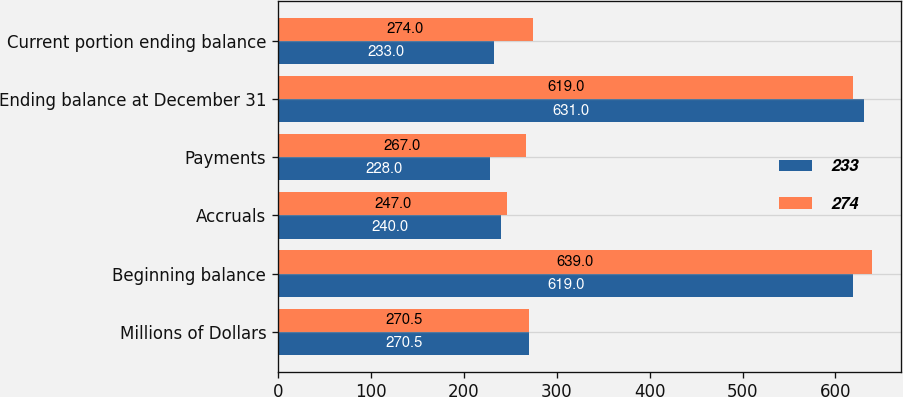Convert chart to OTSL. <chart><loc_0><loc_0><loc_500><loc_500><stacked_bar_chart><ecel><fcel>Millions of Dollars<fcel>Beginning balance<fcel>Accruals<fcel>Payments<fcel>Ending balance at December 31<fcel>Current portion ending balance<nl><fcel>233<fcel>270.5<fcel>619<fcel>240<fcel>228<fcel>631<fcel>233<nl><fcel>274<fcel>270.5<fcel>639<fcel>247<fcel>267<fcel>619<fcel>274<nl></chart> 